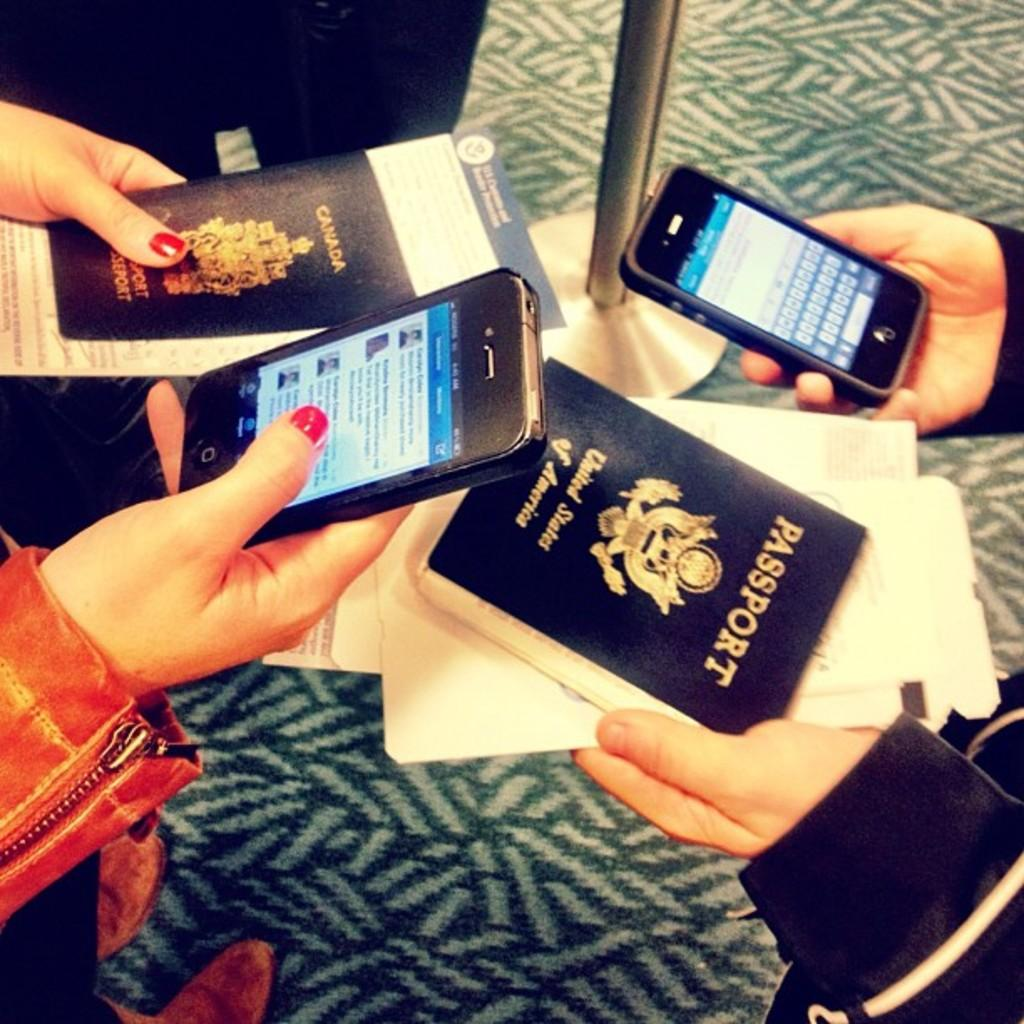Provide a one-sentence caption for the provided image. Two people holding two phones and two passports. 